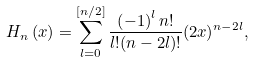<formula> <loc_0><loc_0><loc_500><loc_500>H _ { n } \left ( x \right ) = \sum _ { l = 0 } ^ { \left [ n / 2 \right ] } \frac { \left ( - 1 \right ) ^ { l } n ! } { l ! ( n - 2 l ) ! } ( 2 x ) ^ { n - 2 l } ,</formula> 